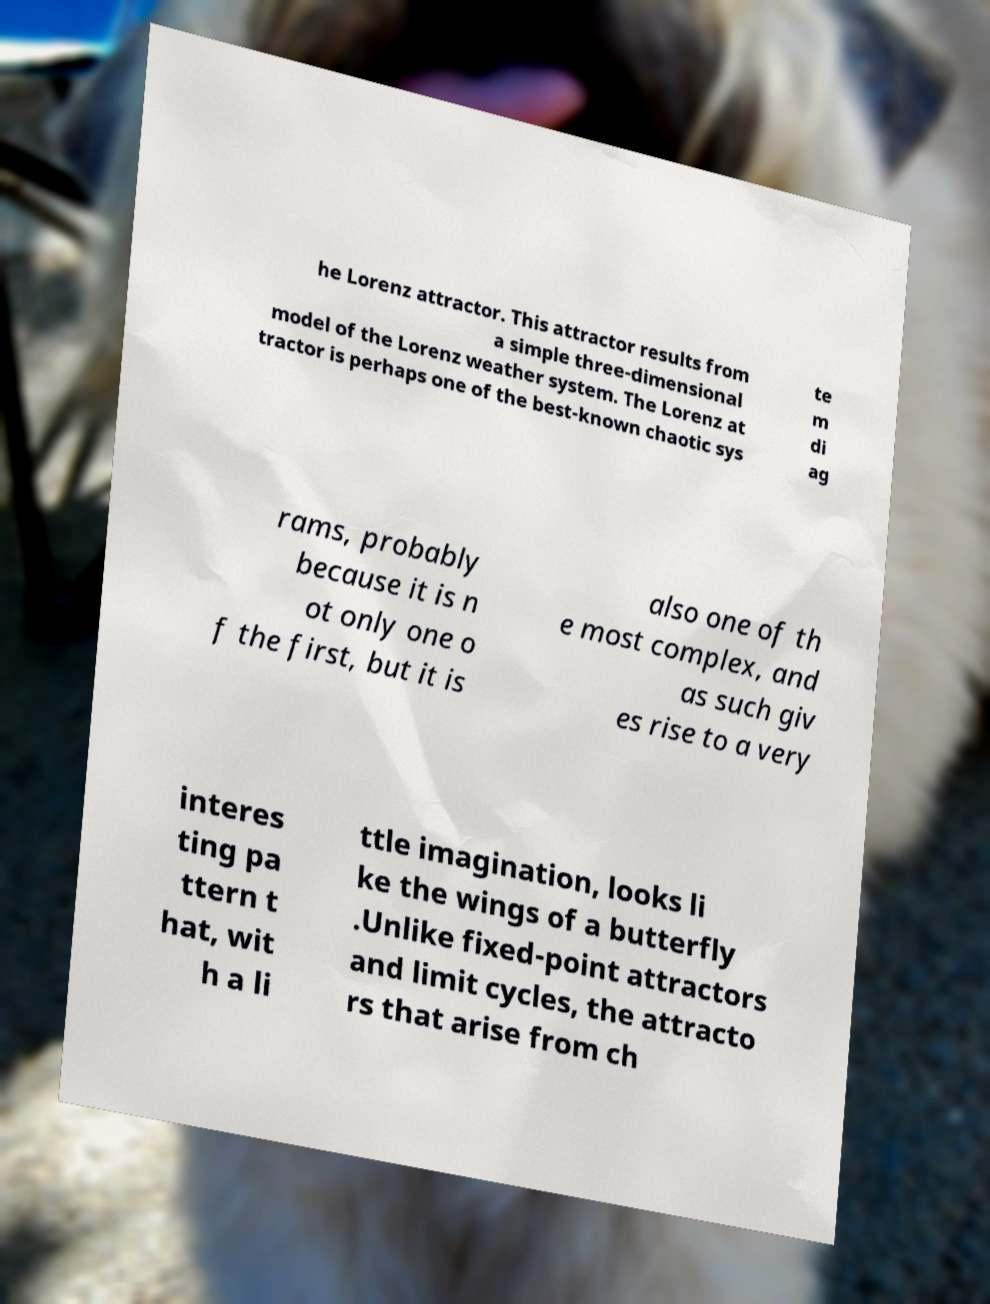Could you assist in decoding the text presented in this image and type it out clearly? he Lorenz attractor. This attractor results from a simple three-dimensional model of the Lorenz weather system. The Lorenz at tractor is perhaps one of the best-known chaotic sys te m di ag rams, probably because it is n ot only one o f the first, but it is also one of th e most complex, and as such giv es rise to a very interes ting pa ttern t hat, wit h a li ttle imagination, looks li ke the wings of a butterfly .Unlike fixed-point attractors and limit cycles, the attracto rs that arise from ch 